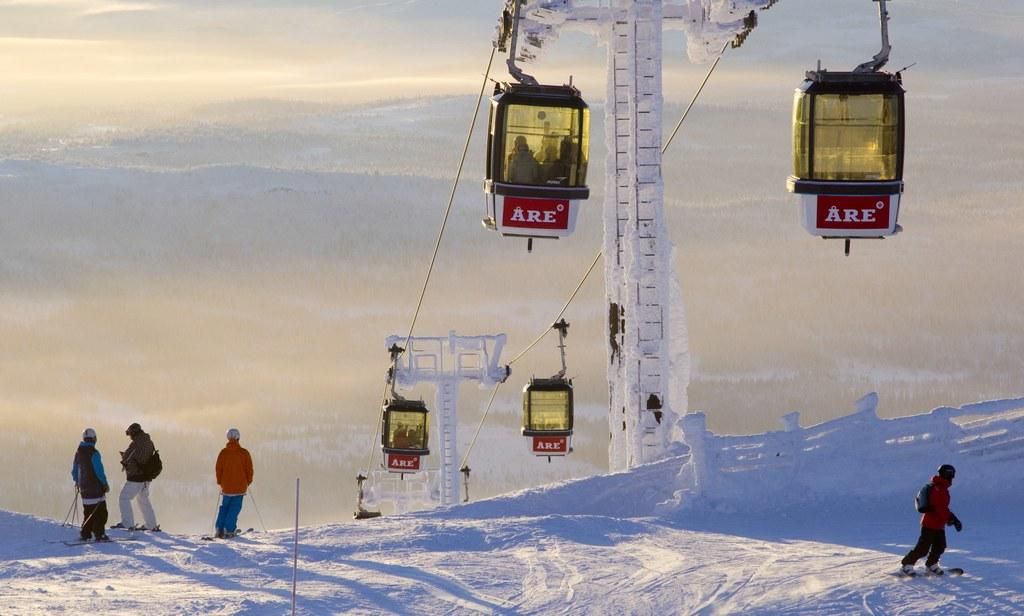What mode of transportation is depicted in the image? There are cable cars in the image. What is located between the cable cars? There is a stand between the cable cars. How is the stand affected by the weather in the image? The stand is covered with snow. What are the persons in the image wearing? The persons are wearing skis in the image. Where are the persons standing in the image? The persons are standing in the snow. How many friends are sleeping on the cable cars in the image? There are no friends or sleeping individuals present in the image. 